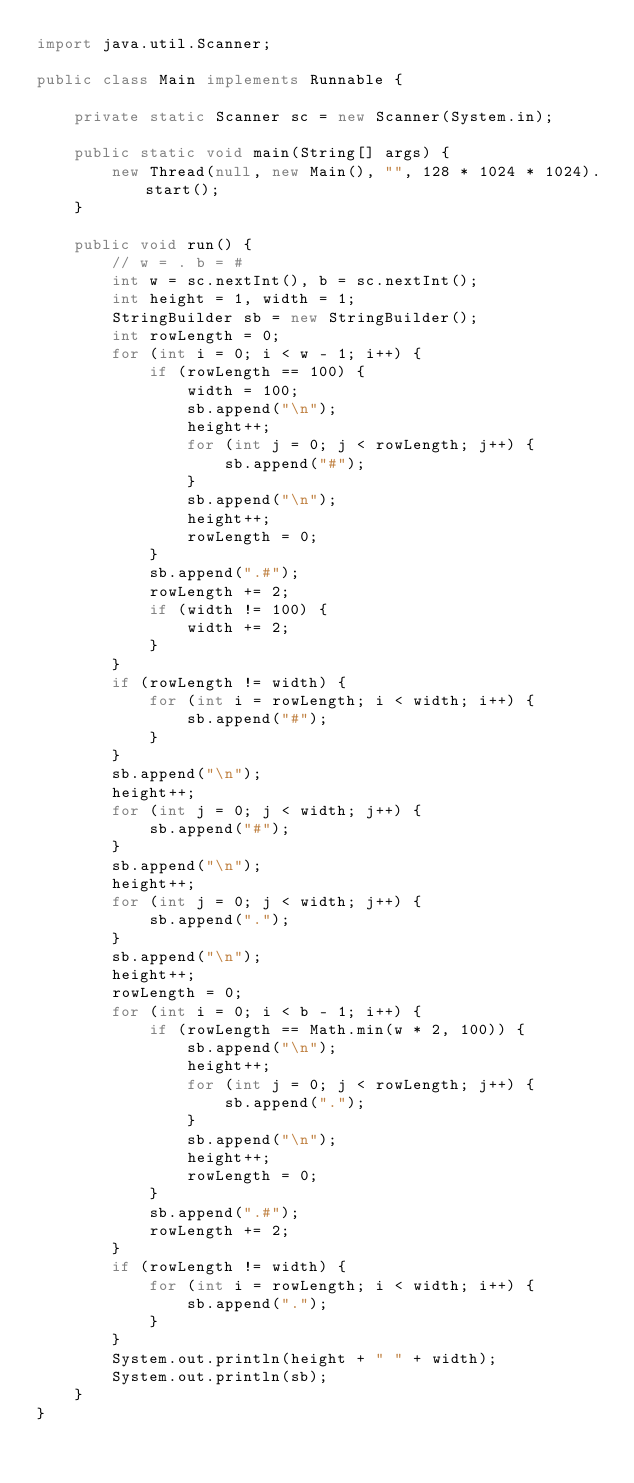<code> <loc_0><loc_0><loc_500><loc_500><_Java_>import java.util.Scanner;

public class Main implements Runnable {

    private static Scanner sc = new Scanner(System.in);

    public static void main(String[] args) {
        new Thread(null, new Main(), "", 128 * 1024 * 1024).start();
    }

    public void run() {
        // w = . b = #
        int w = sc.nextInt(), b = sc.nextInt();
        int height = 1, width = 1;
        StringBuilder sb = new StringBuilder();
        int rowLength = 0;
        for (int i = 0; i < w - 1; i++) {
            if (rowLength == 100) {
                width = 100;
                sb.append("\n");
                height++;
                for (int j = 0; j < rowLength; j++) {
                    sb.append("#");
                }
                sb.append("\n");
                height++;
                rowLength = 0;
            }
            sb.append(".#");
            rowLength += 2;
            if (width != 100) {
                width += 2;
            }
        }
        if (rowLength != width) {
            for (int i = rowLength; i < width; i++) {
                sb.append("#");
            }
        }
        sb.append("\n");
        height++;
        for (int j = 0; j < width; j++) {
            sb.append("#");
        }
        sb.append("\n");
        height++;
        for (int j = 0; j < width; j++) {
            sb.append(".");
        }
        sb.append("\n");
        height++;
        rowLength = 0;
        for (int i = 0; i < b - 1; i++) {
            if (rowLength == Math.min(w * 2, 100)) {
                sb.append("\n");
                height++;
                for (int j = 0; j < rowLength; j++) {
                    sb.append(".");
                }
                sb.append("\n");
                height++;
                rowLength = 0;
            }
            sb.append(".#");
            rowLength += 2;
        }
        if (rowLength != width) {
            for (int i = rowLength; i < width; i++) {
                sb.append(".");
            }
        }
        System.out.println(height + " " + width);
        System.out.println(sb);
    }
}
</code> 